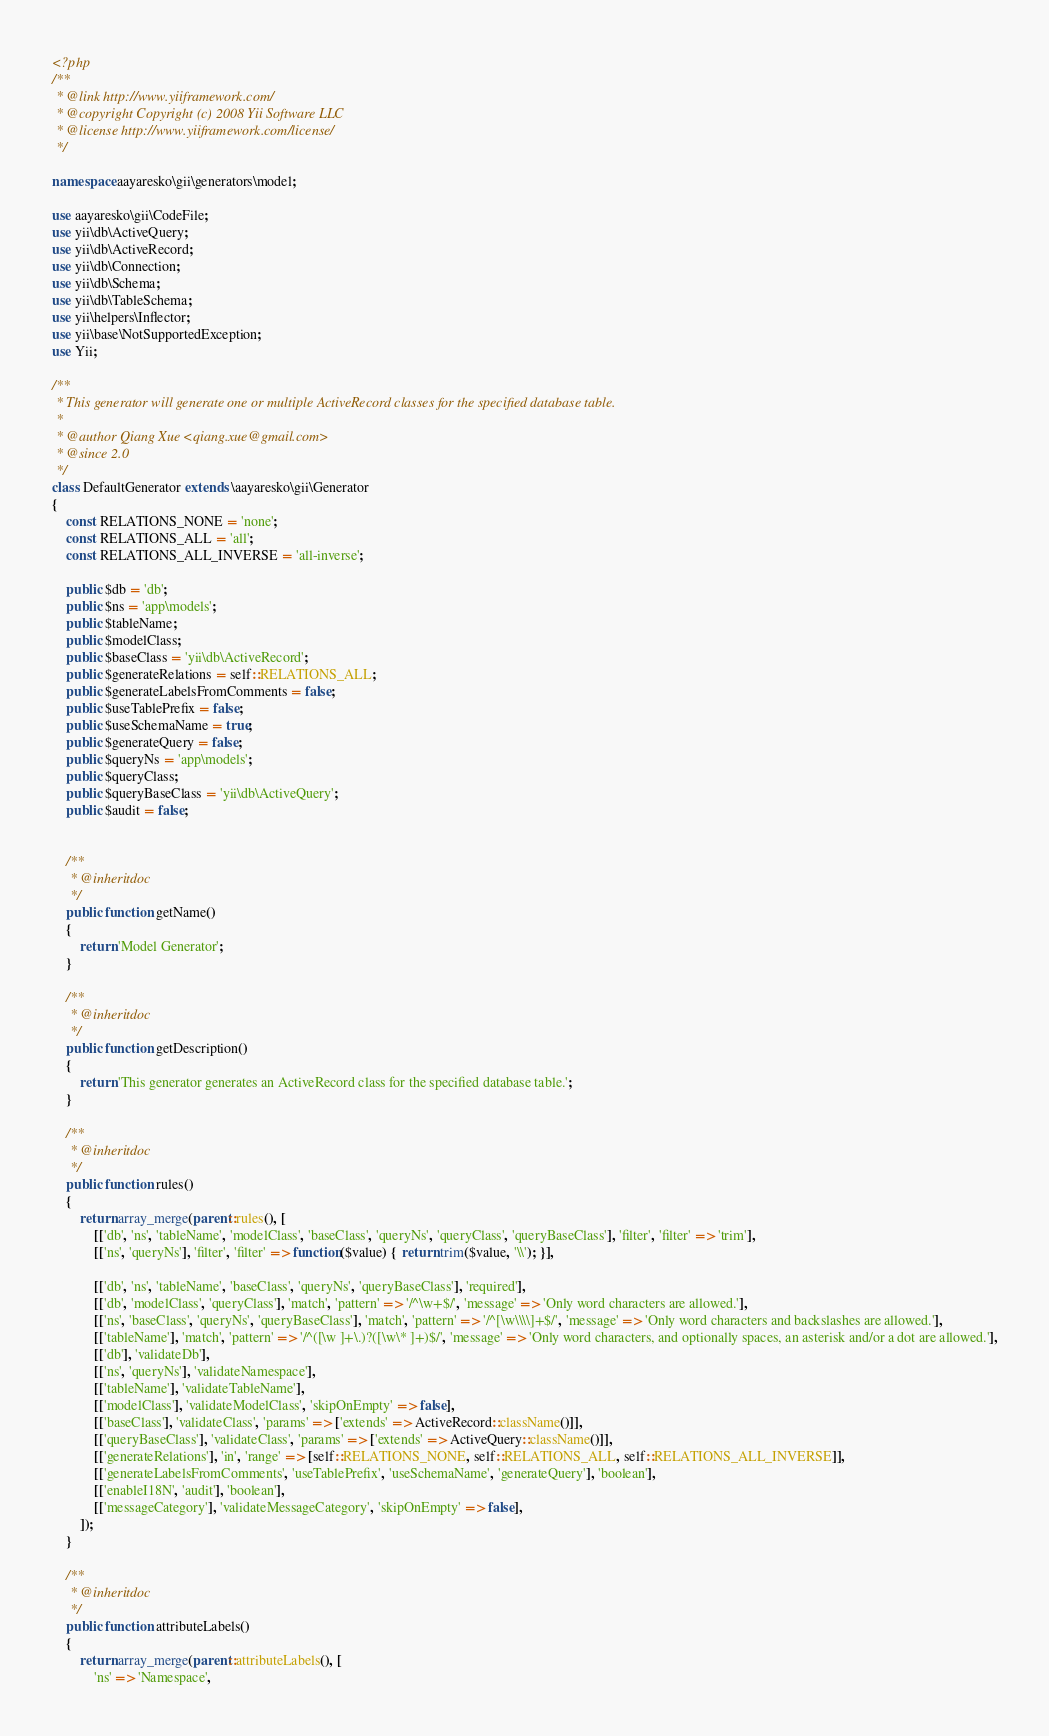Convert code to text. <code><loc_0><loc_0><loc_500><loc_500><_PHP_><?php
/**
 * @link http://www.yiiframework.com/
 * @copyright Copyright (c) 2008 Yii Software LLC
 * @license http://www.yiiframework.com/license/
 */

namespace aayaresko\gii\generators\model;

use aayaresko\gii\CodeFile;
use yii\db\ActiveQuery;
use yii\db\ActiveRecord;
use yii\db\Connection;
use yii\db\Schema;
use yii\db\TableSchema;
use yii\helpers\Inflector;
use yii\base\NotSupportedException;
use Yii;

/**
 * This generator will generate one or multiple ActiveRecord classes for the specified database table.
 *
 * @author Qiang Xue <qiang.xue@gmail.com>
 * @since 2.0
 */
class DefaultGenerator extends \aayaresko\gii\Generator
{
    const RELATIONS_NONE = 'none';
    const RELATIONS_ALL = 'all';
    const RELATIONS_ALL_INVERSE = 'all-inverse';

    public $db = 'db';
    public $ns = 'app\models';
    public $tableName;
    public $modelClass;
    public $baseClass = 'yii\db\ActiveRecord';
    public $generateRelations = self::RELATIONS_ALL;
    public $generateLabelsFromComments = false;
    public $useTablePrefix = false;
    public $useSchemaName = true;
    public $generateQuery = false;
    public $queryNs = 'app\models';
    public $queryClass;
    public $queryBaseClass = 'yii\db\ActiveQuery';
    public $audit = false;


    /**
     * @inheritdoc
     */
    public function getName()
    {
        return 'Model Generator';
    }

    /**
     * @inheritdoc
     */
    public function getDescription()
    {
        return 'This generator generates an ActiveRecord class for the specified database table.';
    }

    /**
     * @inheritdoc
     */
    public function rules()
    {
        return array_merge(parent::rules(), [
            [['db', 'ns', 'tableName', 'modelClass', 'baseClass', 'queryNs', 'queryClass', 'queryBaseClass'], 'filter', 'filter' => 'trim'],
            [['ns', 'queryNs'], 'filter', 'filter' => function($value) { return trim($value, '\\'); }],

            [['db', 'ns', 'tableName', 'baseClass', 'queryNs', 'queryBaseClass'], 'required'],
            [['db', 'modelClass', 'queryClass'], 'match', 'pattern' => '/^\w+$/', 'message' => 'Only word characters are allowed.'],
            [['ns', 'baseClass', 'queryNs', 'queryBaseClass'], 'match', 'pattern' => '/^[\w\\\\]+$/', 'message' => 'Only word characters and backslashes are allowed.'],
            [['tableName'], 'match', 'pattern' => '/^([\w ]+\.)?([\w\* ]+)$/', 'message' => 'Only word characters, and optionally spaces, an asterisk and/or a dot are allowed.'],
            [['db'], 'validateDb'],
            [['ns', 'queryNs'], 'validateNamespace'],
            [['tableName'], 'validateTableName'],
            [['modelClass'], 'validateModelClass', 'skipOnEmpty' => false],
            [['baseClass'], 'validateClass', 'params' => ['extends' => ActiveRecord::className()]],
            [['queryBaseClass'], 'validateClass', 'params' => ['extends' => ActiveQuery::className()]],
            [['generateRelations'], 'in', 'range' => [self::RELATIONS_NONE, self::RELATIONS_ALL, self::RELATIONS_ALL_INVERSE]],
            [['generateLabelsFromComments', 'useTablePrefix', 'useSchemaName', 'generateQuery'], 'boolean'],
            [['enableI18N', 'audit'], 'boolean'],
            [['messageCategory'], 'validateMessageCategory', 'skipOnEmpty' => false],
        ]);
    }

    /**
     * @inheritdoc
     */
    public function attributeLabels()
    {
        return array_merge(parent::attributeLabels(), [
            'ns' => 'Namespace',</code> 